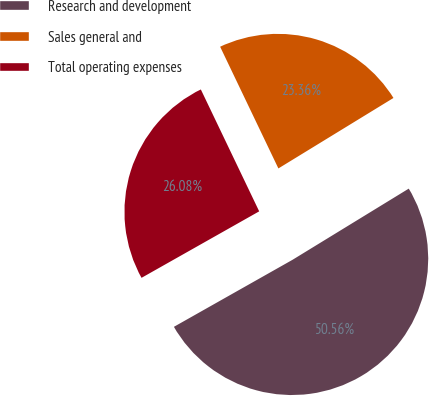Convert chart to OTSL. <chart><loc_0><loc_0><loc_500><loc_500><pie_chart><fcel>Research and development<fcel>Sales general and<fcel>Total operating expenses<nl><fcel>50.56%<fcel>23.36%<fcel>26.08%<nl></chart> 